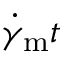<formula> <loc_0><loc_0><loc_500><loc_500>\dot { \gamma } _ { m } t</formula> 